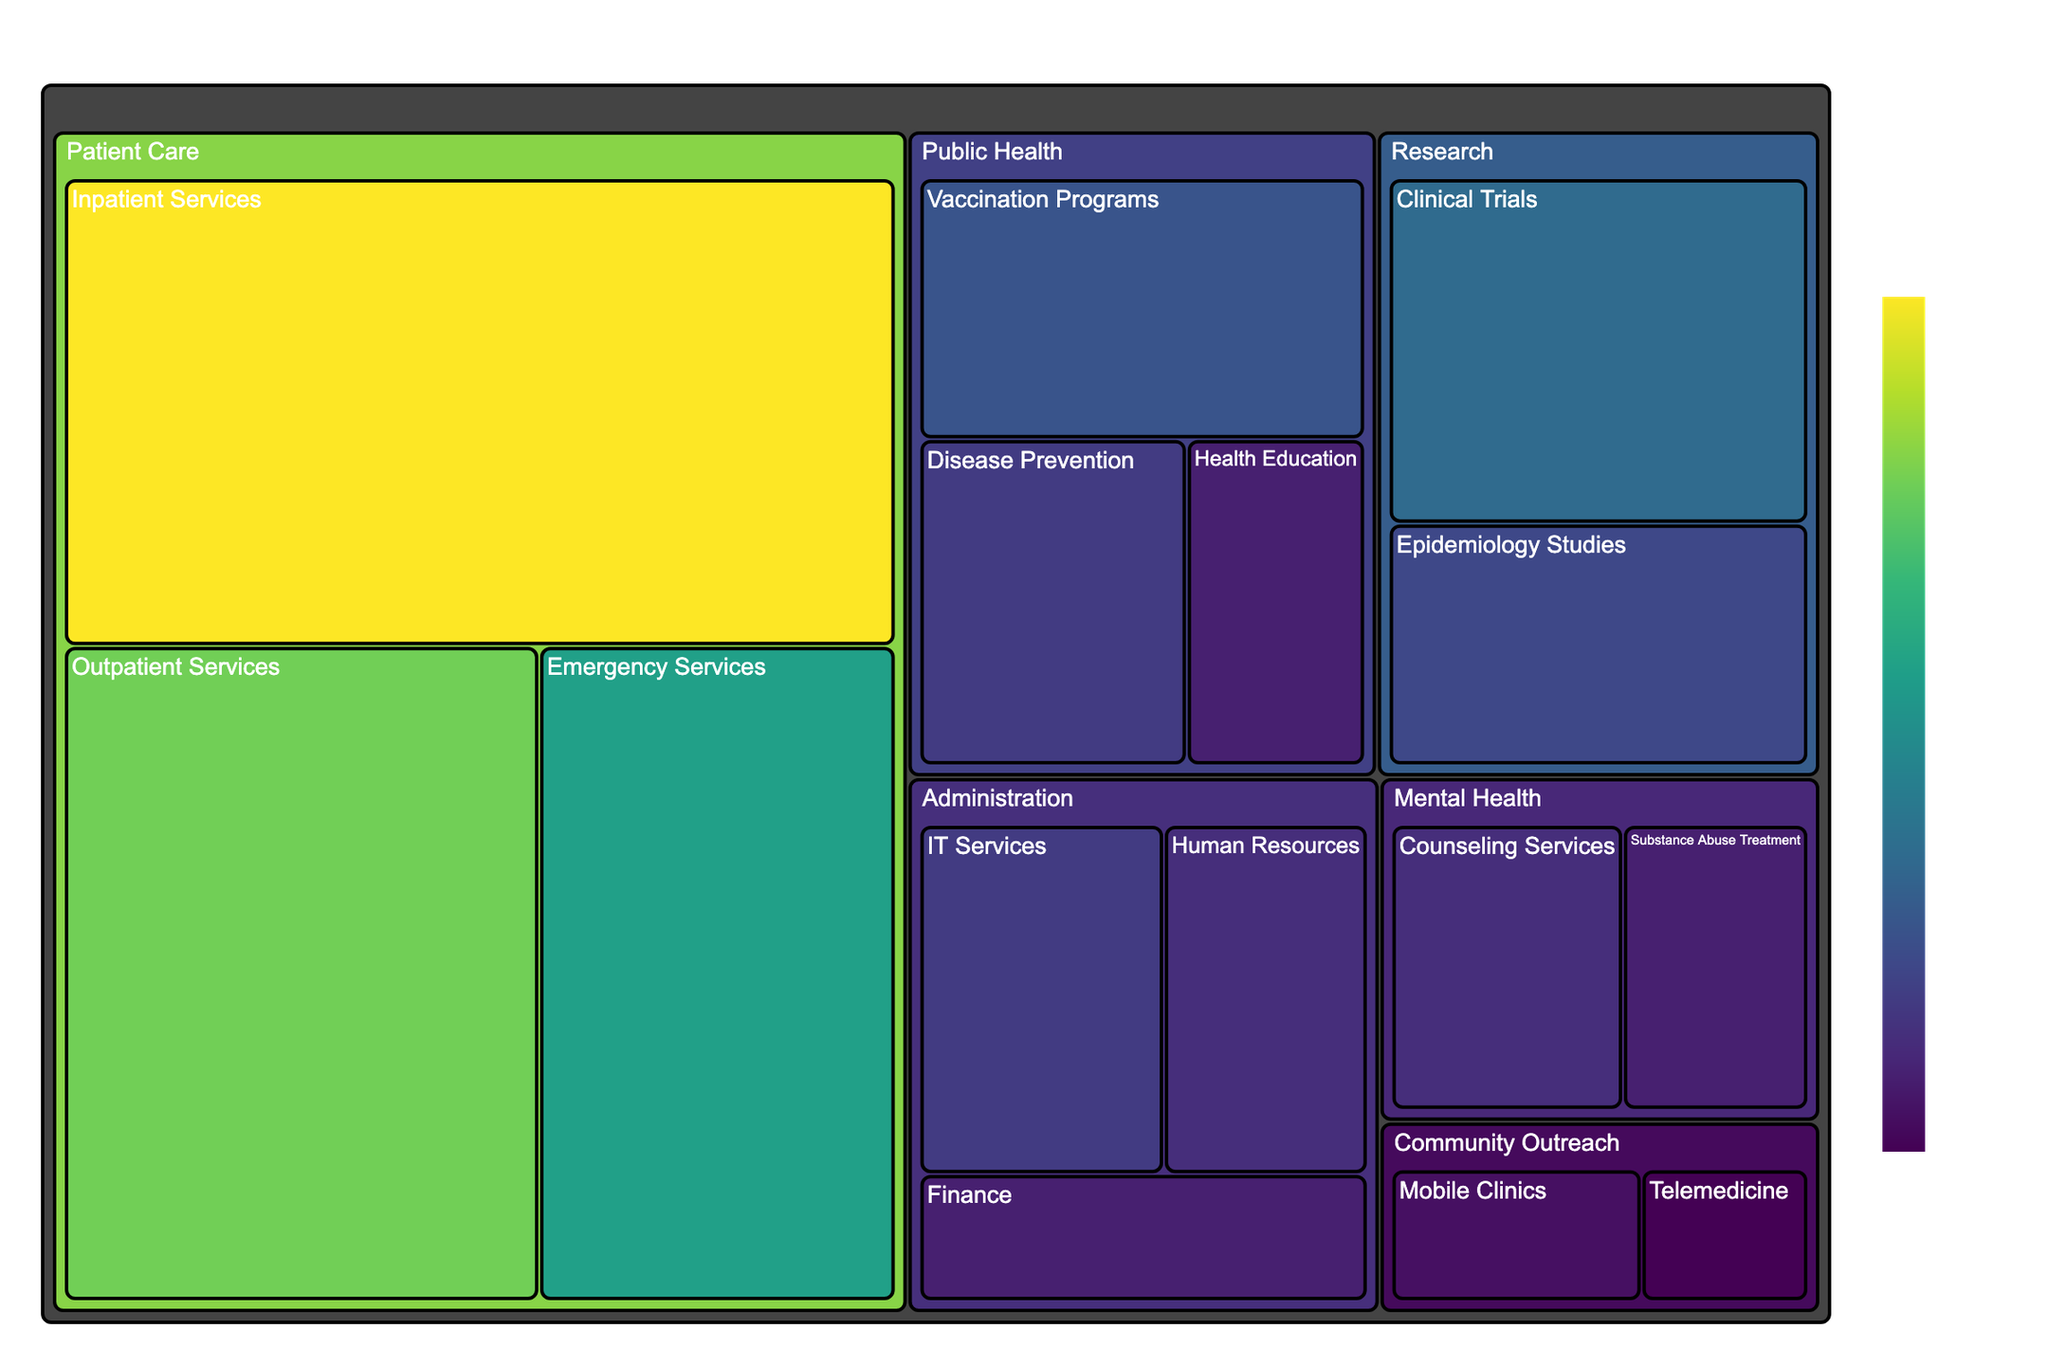What's the title of the treemap? The title of the treemap is prominently displayed at the top center of the figure. It directly indicates the subject of the data visualization.
Answer: Healthcare Budget Allocation Which program has the highest budget? The program with the largest area in the treemap represents the program with the highest budget. In this case, it can be visually identified as 'Inpatient Services' under the 'Patient Care' department.
Answer: Inpatient Services What is the total budget allocated to the Public Health department? To find the total budget for the Public Health department, sum the budgets of its programs: Vaccination Programs ($8,000,000), Disease Prevention ($6,000,000), and Health Education ($4,000,000).
Answer: $18,000,000 How does the budget for Mental Health compare to the budget for Community Outreach? To compare, sum the budgets for each department. Mental Health: Counseling Services ($5,000,000) + Substance Abuse Treatment ($4,000,000) = $9,000,000. Community Outreach: Mobile Clinics ($3,000,000) + Telemedicine ($2,000,000) = $5,000,000. Mental Health's budget is larger by $4,000,000.
Answer: Mental Health: $9,000,000, Community Outreach: $5,000,000 Which department has the smallest total budget allocated? The smallest total budget can be identified by summing the budgets of all programs in each department and comparing. Administration: Human Resources ($5,000,000) + Finance ($4,000,000) + IT Services ($6,000,000) = $15,000,000. Community Outreach: Mobile Clinics ($3,000,000) + Telemedicine ($2,000,000) = $5,000,000. Mental Health: Counseling Services ($5,000,000) + Substance Abuse Treatment ($4,000,000) = $9,000,000. Research: Clinical Trials ($10,000,000) + Epidemiology Studies ($7,000,000) = $17,000,000. Public Health: Vaccination Programs ($8,000,000) + Disease Prevention ($6,000,000) + Health Education ($4,000,000) = $18,000,000. Patient Care: Emergency Services ($15,000,000) + Inpatient Services ($25,000,000) + Outpatient Services ($20,000,000) = $60,000,000. Thus, Community Outreach has the smallest total budget.
Answer: Community Outreach What's the budget for Inpatient Services represented in the figure? The budget is displayed in the hover-over information on the figure. For Inpatient Services, it shows $25,000,000.
Answer: $25,000,000 Compare the budget allocated to Disease Prevention and Epidemiology Studies, and identify which one received more funding. Looking at the figure, the budget for Disease Prevention is $6,000,000, whereas Epidemiology Studies has a budget of $7,000,000. Epidemiology Studies received more funding.
Answer: Epidemiology Studies What proportion of the total budget is allocated to Patient Care? Total budget across all departments is calculated first: 
Patient Care ($60,000,000) + Public Health ($18,000,000) + Research ($17,000,000) + Administration ($15,000,000) + Community Outreach ($5,000,000) + Mental Health ($9,000,000) = $124,000,000. 
Proportion for Patient Care: $60,000,000 / $124,000,000 ≈ 0.4839 ≈ 48.39%.
Answer: 48.39% What is the difference in the budget between IT Services and Finance? IT Services has a budget of $6,000,000 and Finance $4,000,000. The difference is $6,000,000 - $4,000,000 = $2,000,000.
Answer: $2,000,000 How are the colors used in the figure related to the budget? The colors on the treemap range from lighter to darker shades of a color (e.g., Viridis). Darker shades represent higher budgets, while lighter shades represent lower budgets. This color gradient helps visualize budget differences among the programs.
Answer: Darker shades represent higher budgets 